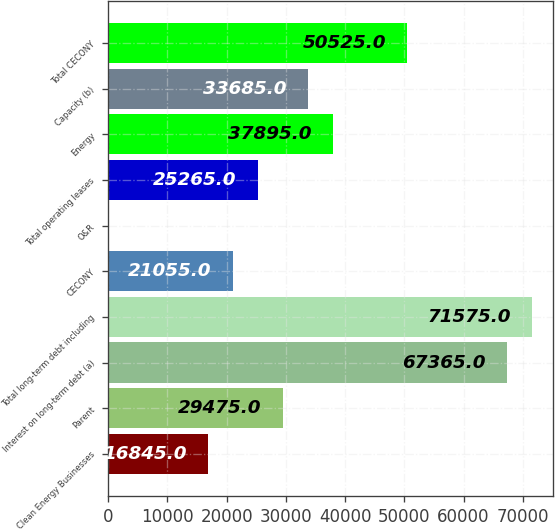<chart> <loc_0><loc_0><loc_500><loc_500><bar_chart><fcel>Clean Energy Businesses<fcel>Parent<fcel>Interest on long-term debt (a)<fcel>Total long-term debt including<fcel>CECONY<fcel>O&R<fcel>Total operating leases<fcel>Energy<fcel>Capacity (b)<fcel>Total CECONY<nl><fcel>16845<fcel>29475<fcel>67365<fcel>71575<fcel>21055<fcel>5<fcel>25265<fcel>37895<fcel>33685<fcel>50525<nl></chart> 